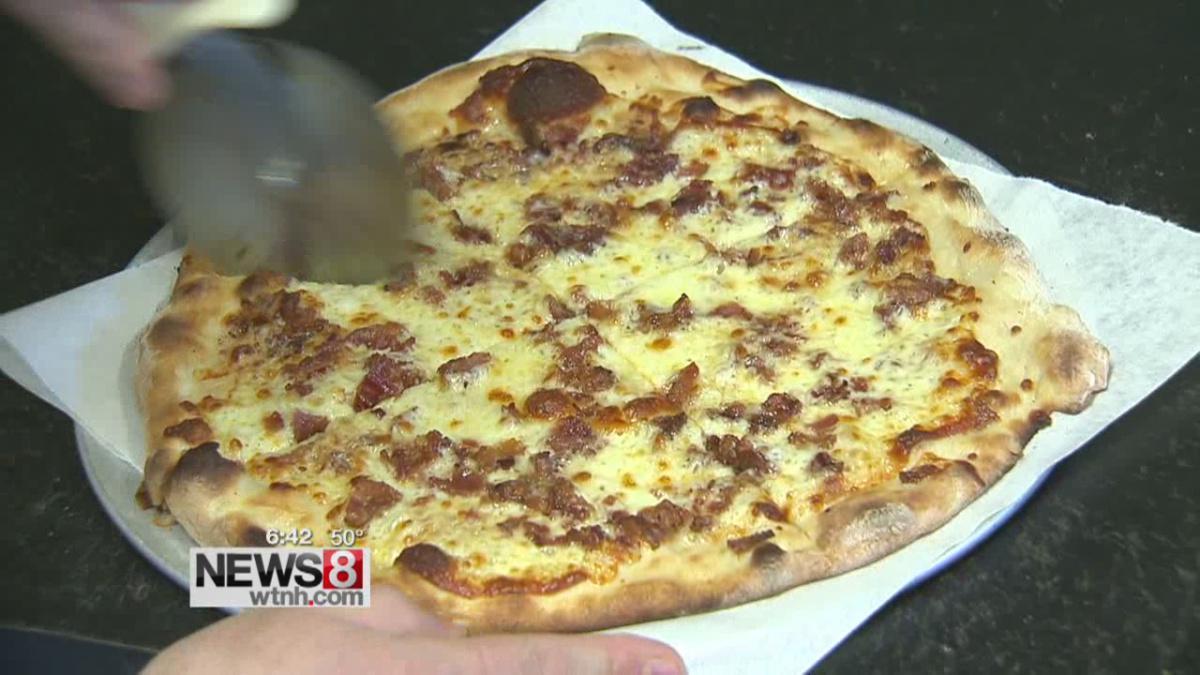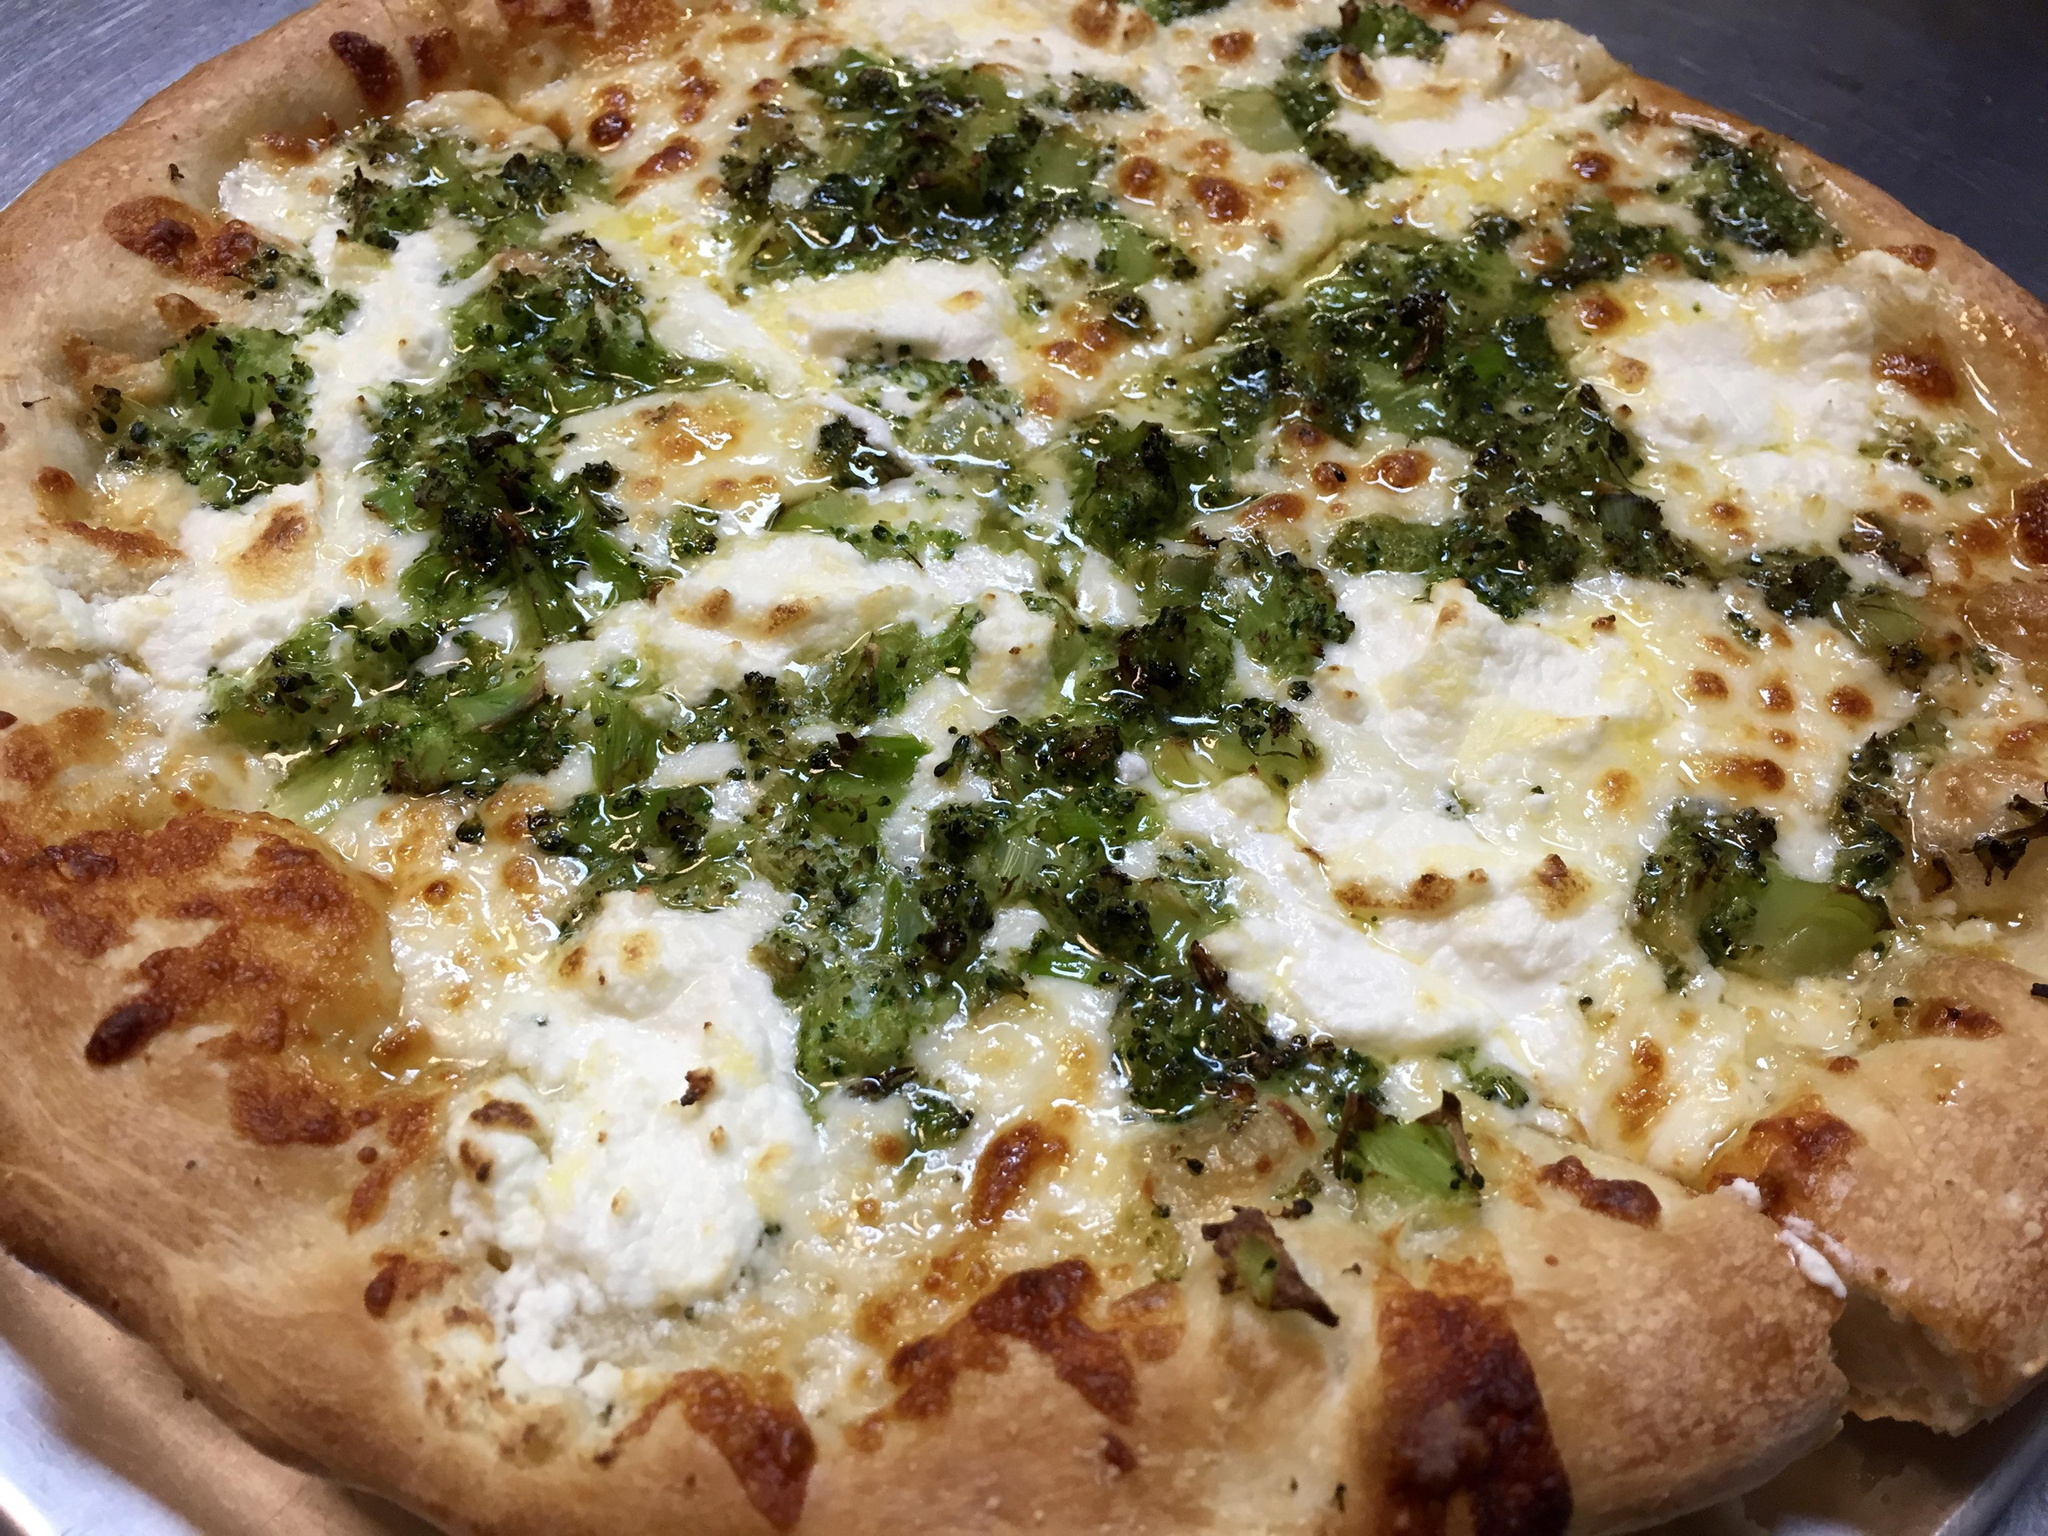The first image is the image on the left, the second image is the image on the right. Considering the images on both sides, is "The left and right image contains the same number of pizzas with at least on sitting on paper." valid? Answer yes or no. Yes. The first image is the image on the left, the second image is the image on the right. Given the left and right images, does the statement "The left image shows a tool with a handle and a flat metal part being applied to a round pizza." hold true? Answer yes or no. Yes. 